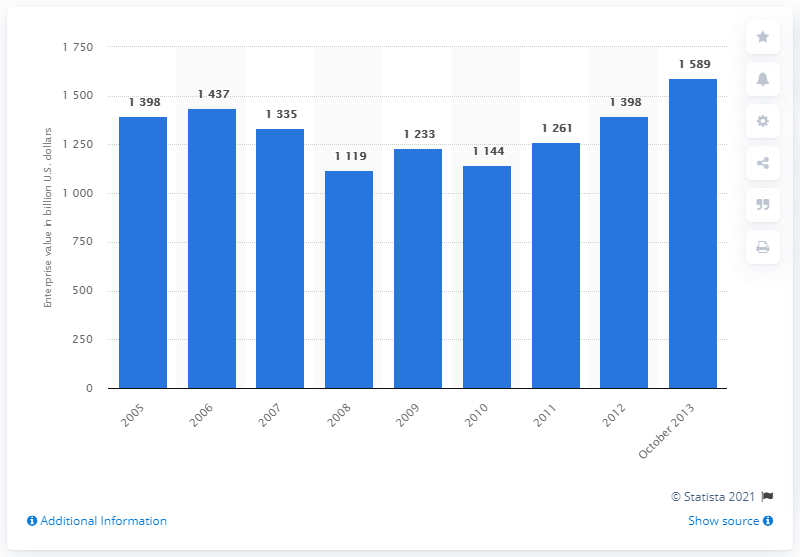Identify some key points in this picture. In 2005, the enterprise value of pure play pharmaceutical peers was $1,398. The enterprise value of the selected pharmaceutical companies as of October 2013 was approximately 1589. 